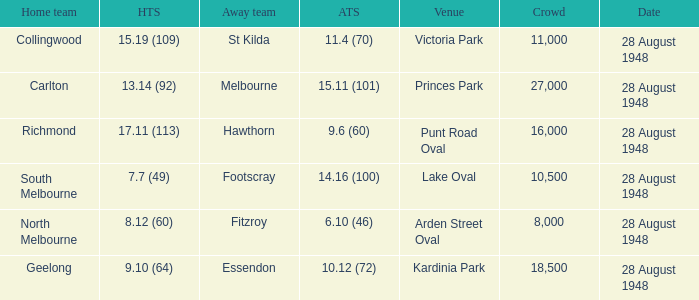What is the St Kilda Away team score? 11.4 (70). 